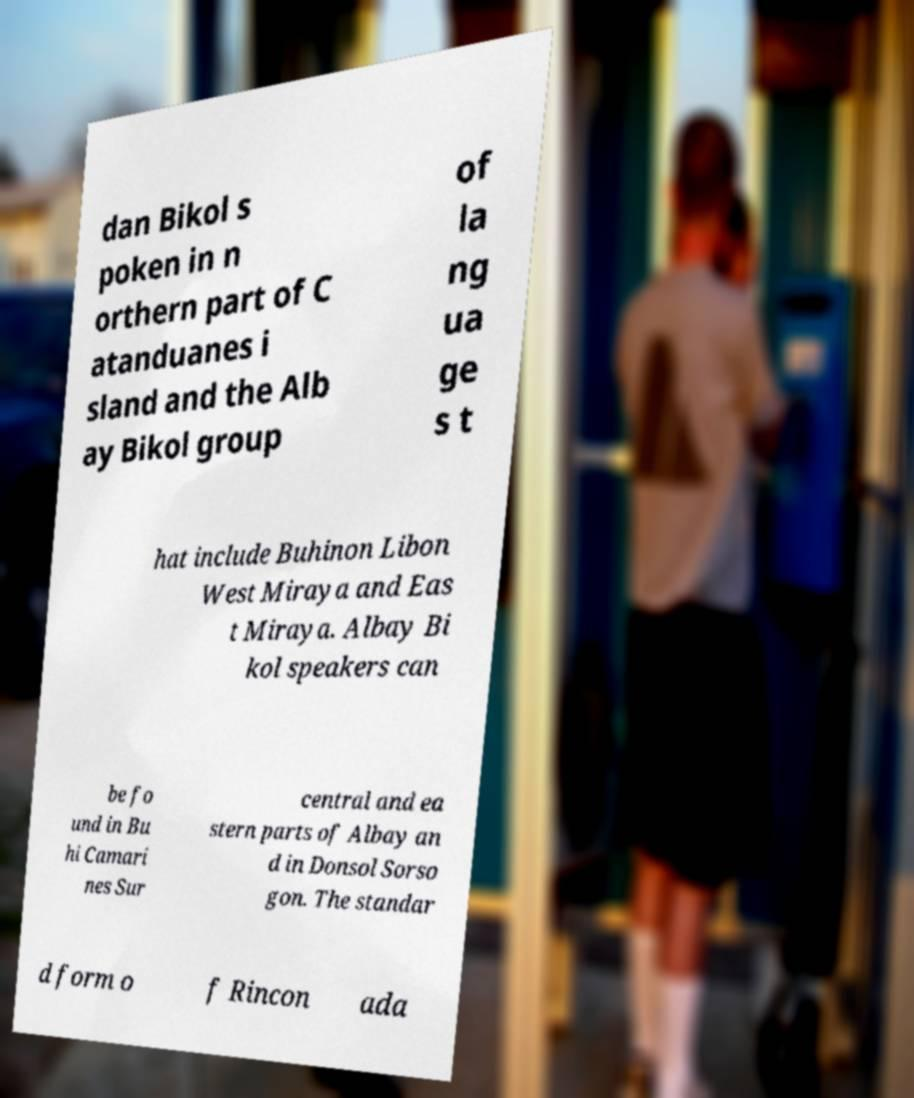What messages or text are displayed in this image? I need them in a readable, typed format. dan Bikol s poken in n orthern part of C atanduanes i sland and the Alb ay Bikol group of la ng ua ge s t hat include Buhinon Libon West Miraya and Eas t Miraya. Albay Bi kol speakers can be fo und in Bu hi Camari nes Sur central and ea stern parts of Albay an d in Donsol Sorso gon. The standar d form o f Rincon ada 